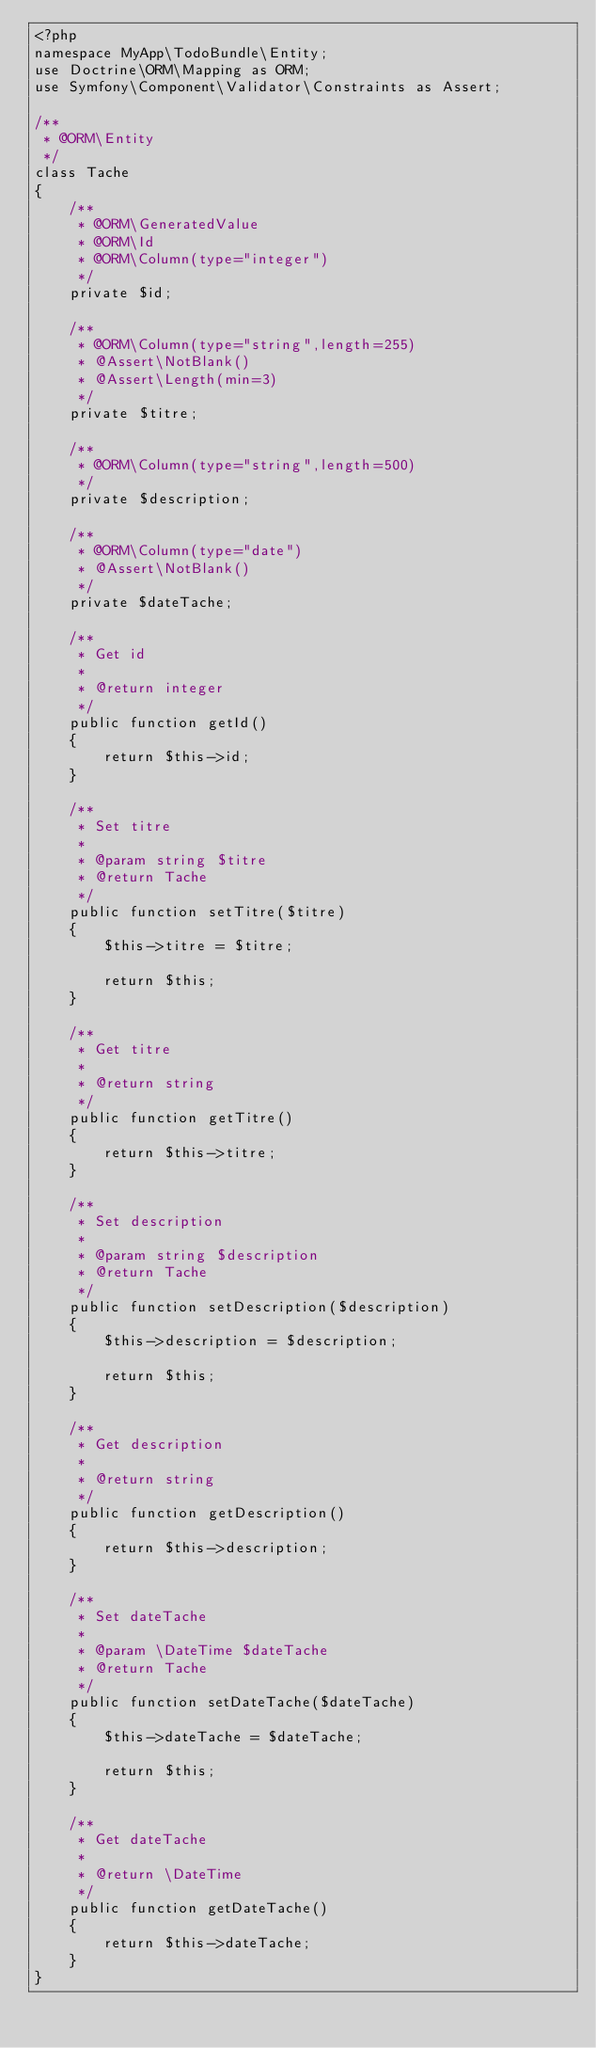<code> <loc_0><loc_0><loc_500><loc_500><_PHP_><?php
namespace MyApp\TodoBundle\Entity;
use Doctrine\ORM\Mapping as ORM;
use Symfony\Component\Validator\Constraints as Assert;

/**
 * @ORM\Entity
 */
class Tache
{
    /**
     * @ORM\GeneratedValue
     * @ORM\Id
     * @ORM\Column(type="integer")
     */
    private $id;
    
    /**
     * @ORM\Column(type="string",length=255)
     * @Assert\NotBlank()
     * @Assert\Length(min=3)
     */    
    private $titre;

    /**
     * @ORM\Column(type="string",length=500)
     */    
    private $description;

    /**
     * @ORM\Column(type="date")
     * @Assert\NotBlank()
     */    
    private $dateTache;

    /**
     * Get id
     *
     * @return integer 
     */
    public function getId()
    {
        return $this->id;
    }

    /**
     * Set titre
     *
     * @param string $titre
     * @return Tache
     */
    public function setTitre($titre)
    {
        $this->titre = $titre;

        return $this;
    }

    /**
     * Get titre
     *
     * @return string 
     */
    public function getTitre()
    {
        return $this->titre;
    }

    /**
     * Set description
     *
     * @param string $description
     * @return Tache
     */
    public function setDescription($description)
    {
        $this->description = $description;

        return $this;
    }

    /**
     * Get description
     *
     * @return string 
     */
    public function getDescription()
    {
        return $this->description;
    }

    /**
     * Set dateTache
     *
     * @param \DateTime $dateTache
     * @return Tache
     */
    public function setDateTache($dateTache)
    {
        $this->dateTache = $dateTache;

        return $this;
    }

    /**
     * Get dateTache
     *
     * @return \DateTime 
     */
    public function getDateTache()
    {
        return $this->dateTache;
    }
}
</code> 